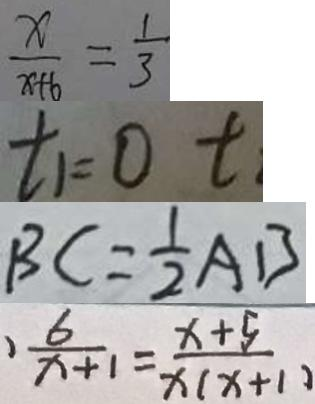Convert formula to latex. <formula><loc_0><loc_0><loc_500><loc_500>\frac { x } { x + 6 } = \frac { 1 } { 3 } 
 t _ { 1 } = 0 t 
 B C = \frac { 1 } { 2 } A B 
 \frac { 6 } { x + 1 } = \frac { x + 5 } { x ( x + 1 ) }</formula> 